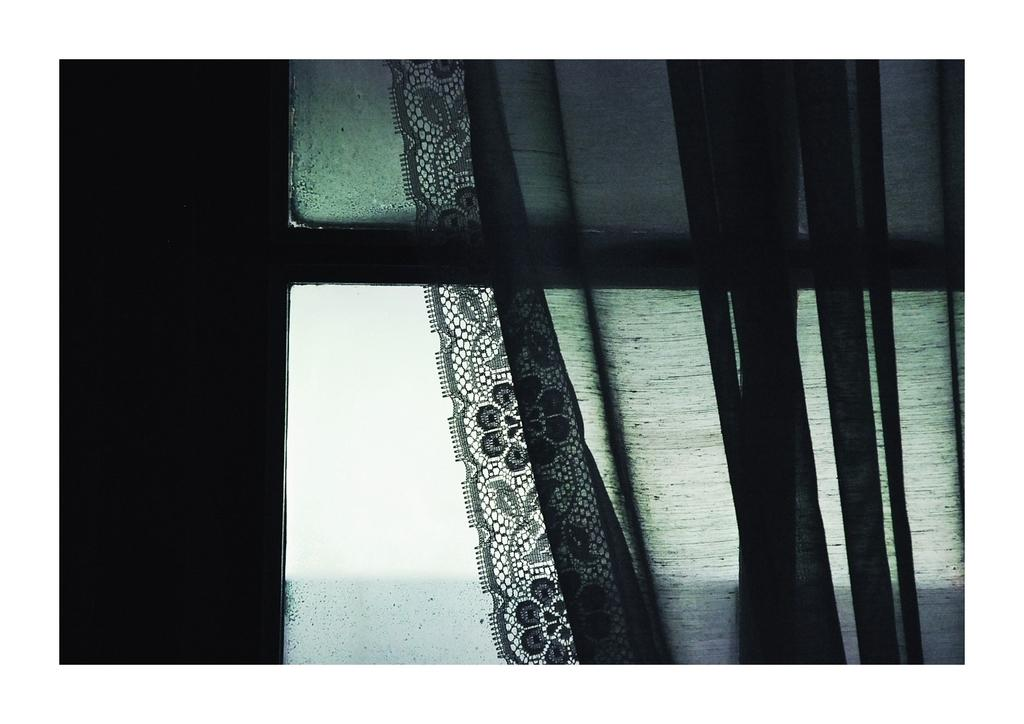What is covering the window in the image? There is a curtain on the window, and there is also a knitted lace on the window. What can you tell about the color scheme of the image? The image is in black and white color. What type of thrill can be seen on the canvas in the image? There is no canvas or thrill present in the image. The image is in black and white color and features a curtain and a knitted lace on the window. 